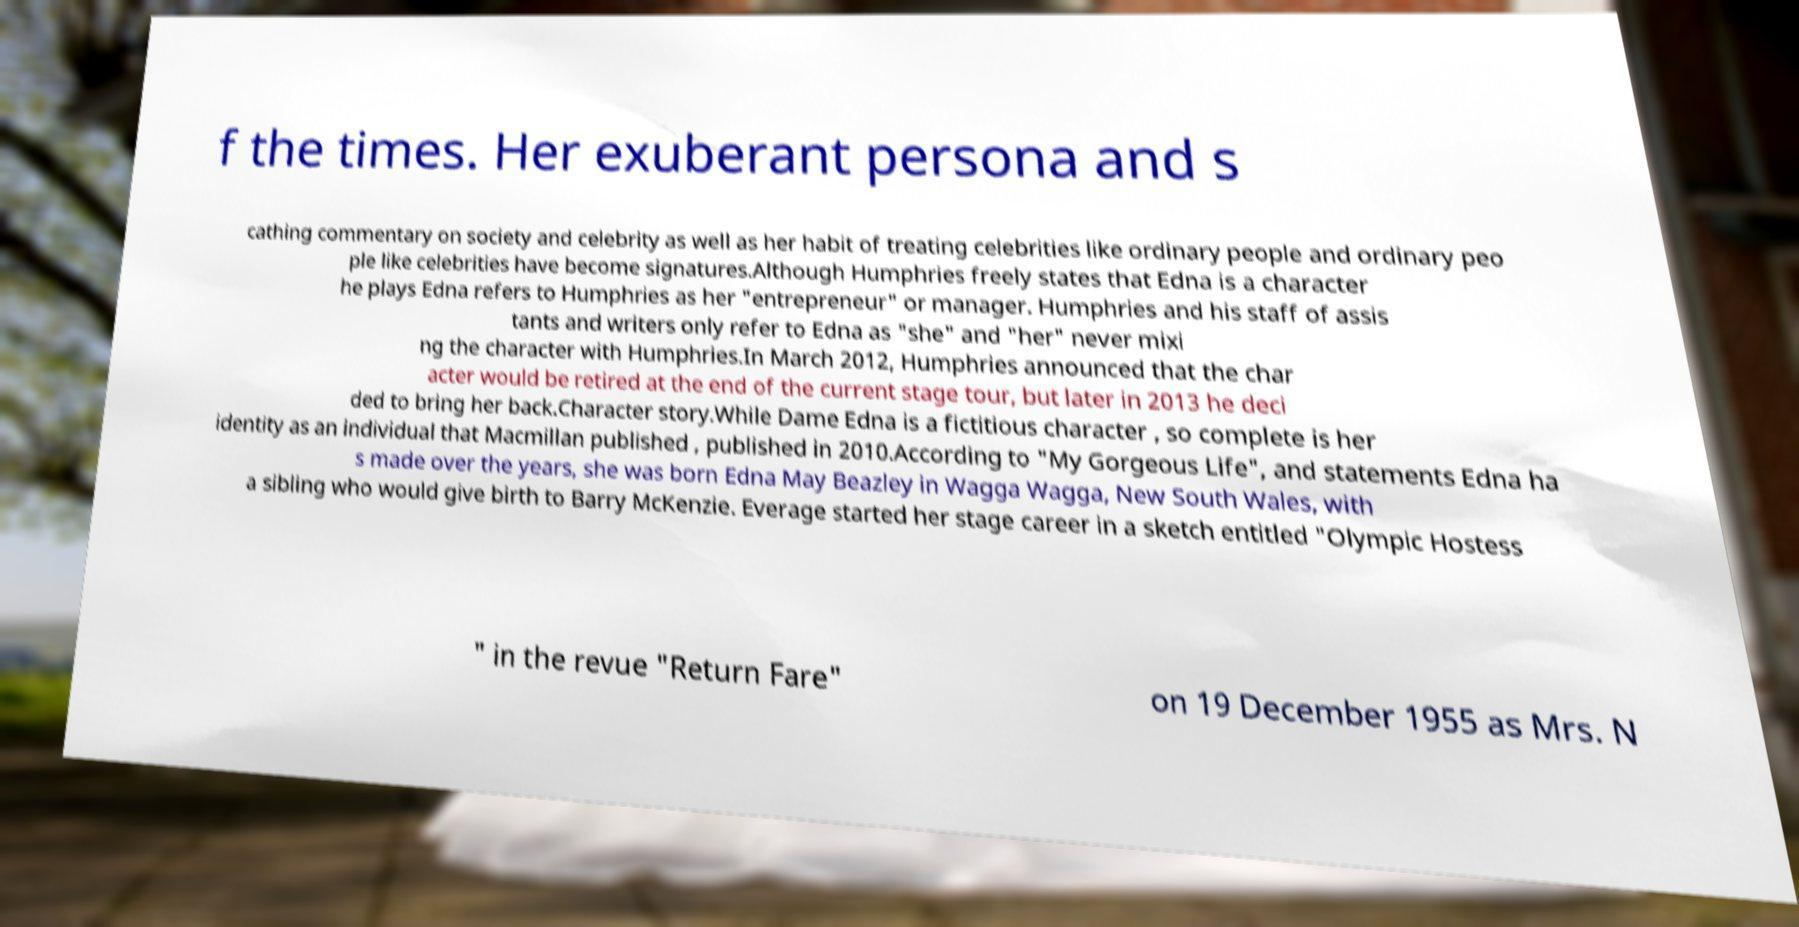For documentation purposes, I need the text within this image transcribed. Could you provide that? f the times. Her exuberant persona and s cathing commentary on society and celebrity as well as her habit of treating celebrities like ordinary people and ordinary peo ple like celebrities have become signatures.Although Humphries freely states that Edna is a character he plays Edna refers to Humphries as her "entrepreneur" or manager. Humphries and his staff of assis tants and writers only refer to Edna as "she" and "her" never mixi ng the character with Humphries.In March 2012, Humphries announced that the char acter would be retired at the end of the current stage tour, but later in 2013 he deci ded to bring her back.Character story.While Dame Edna is a fictitious character , so complete is her identity as an individual that Macmillan published , published in 2010.According to "My Gorgeous Life", and statements Edna ha s made over the years, she was born Edna May Beazley in Wagga Wagga, New South Wales, with a sibling who would give birth to Barry McKenzie. Everage started her stage career in a sketch entitled "Olympic Hostess " in the revue "Return Fare" on 19 December 1955 as Mrs. N 